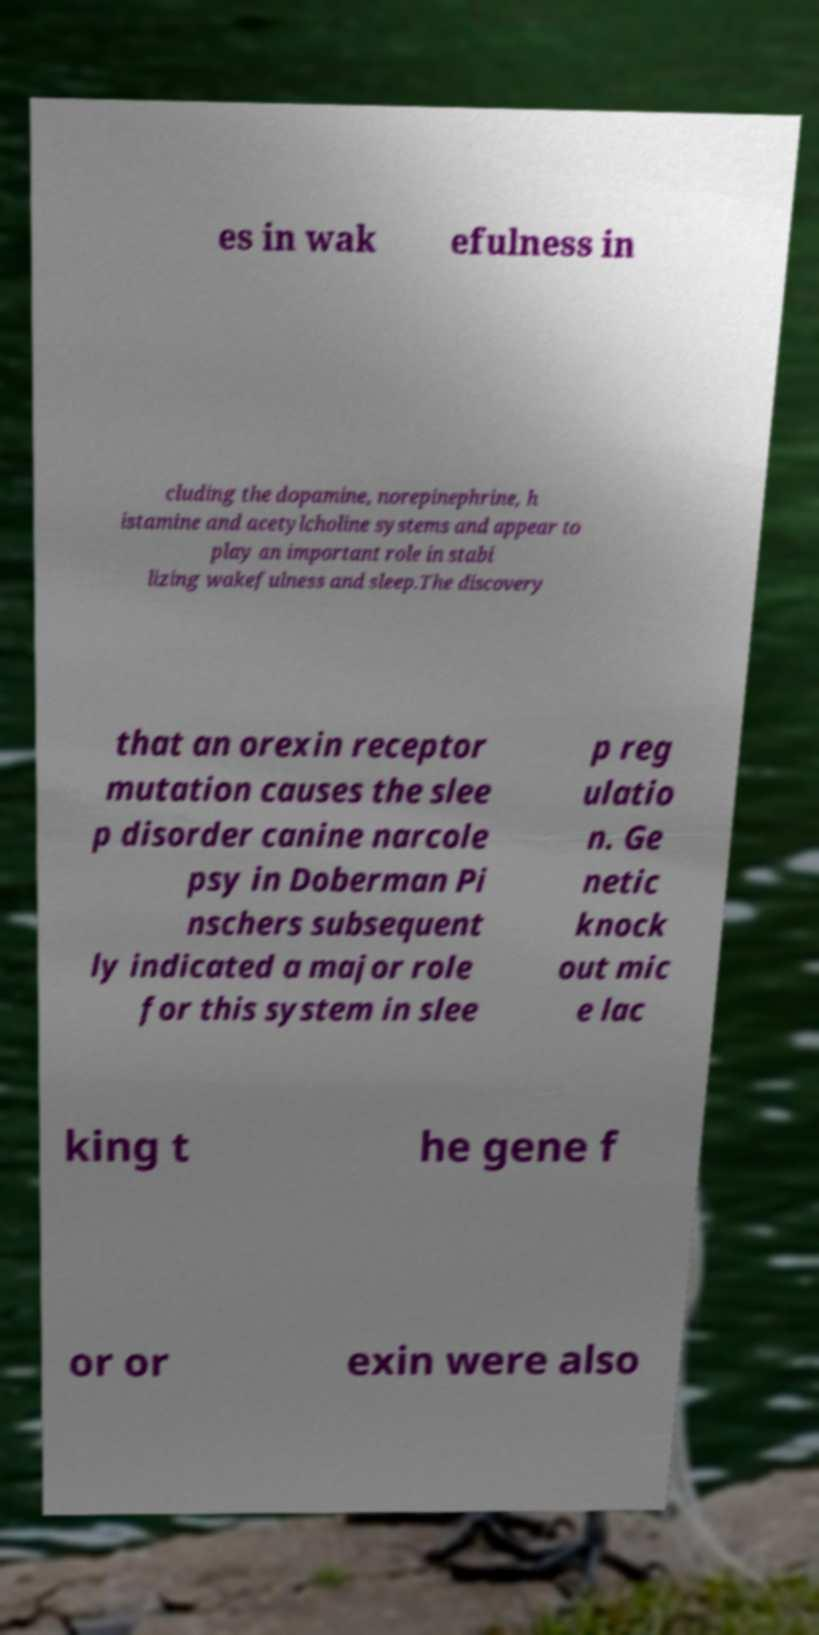Could you assist in decoding the text presented in this image and type it out clearly? es in wak efulness in cluding the dopamine, norepinephrine, h istamine and acetylcholine systems and appear to play an important role in stabi lizing wakefulness and sleep.The discovery that an orexin receptor mutation causes the slee p disorder canine narcole psy in Doberman Pi nschers subsequent ly indicated a major role for this system in slee p reg ulatio n. Ge netic knock out mic e lac king t he gene f or or exin were also 